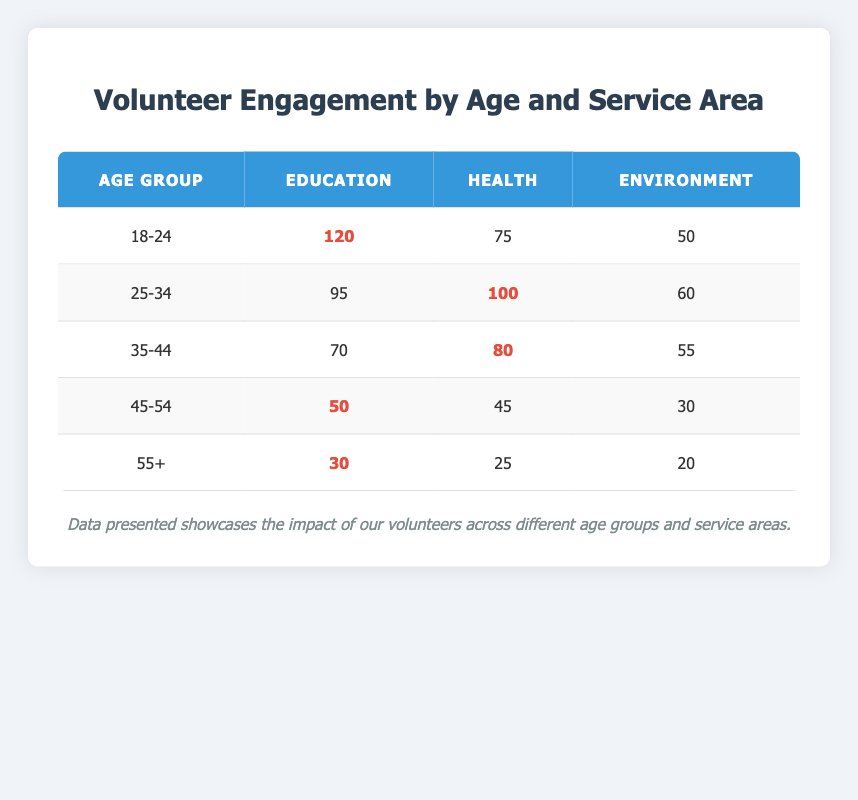What is the total number of volunteers in the Education area of service? To find the total number of volunteers in the Education area, we add the volunteers from all age groups: 120 (18-24) + 95 (25-34) + 70 (35-44) + 50 (45-54) + 30 (55+) = 365.
Answer: 365 Which age group has the highest number of volunteers in the Health area? The number of volunteers in the Health area for each age group is: 75 (18-24), 100 (25-34), 80 (35-44), 45 (45-54), and 25 (55+). The highest number is 100 from the 25-34 age group.
Answer: 25-34 Is there a higher number of volunteers in the Environment area for the 25-34 age group compared to the 18-24 age group? For the Environment area, the 25-34 age group has 60 volunteers, while the 18-24 age group has 50 volunteers. Since 60 is greater than 50, the statement is true.
Answer: Yes What is the average number of volunteers across all age groups in the Health area? To calculate the average number of volunteers in the Health area, we first sum the volunteers: 75 (18-24) + 100 (25-34) + 80 (35-44) + 45 (45-54) + 25 (55+) = 325. Then, we divide by 5 (the number of age groups), so 325 / 5 = 65.
Answer: 65 How many more volunteers are there in the Education area compared to the Environment area in total? The total in the Education area is 365 (as calculated before), and the total in the Environment area is: 50 (18-24) + 60 (25-34) + 55 (35-44) + 30 (45-54) + 20 (55+) = 215. To find the difference, we subtract: 365 - 215 = 150.
Answer: 150 Which area of service has the least engagement from the 55+ age group? Looking at the 55+ age group: Education has 30 volunteers, Health has 25 volunteers, and Environment has 20 volunteers. The least engagement is in the Environment area with 20 volunteers.
Answer: Environment Are there any age groups that have exactly the same number of volunteers in a specific area of service? After examining the table, the 45-54 age group has 45 volunteers in Health and the 55+ age group has 45 volunteers in the same area; however, no specific area of service is shared across different age groups. Thus, the answer is no.
Answer: No What is the percentage of volunteers in the Education area out of the total volunteers across all areas? First, we need to calculate the total volunteers across all areas: 365 (Education) + 325 (Health) + 215 (Environment) = 905. Then, we take the number of volunteers in Education (365) and divide it by the total (905), then multiply by 100 to get the percentage: (365 / 905) * 100 ≈ 40.4%.
Answer: 40.4% 